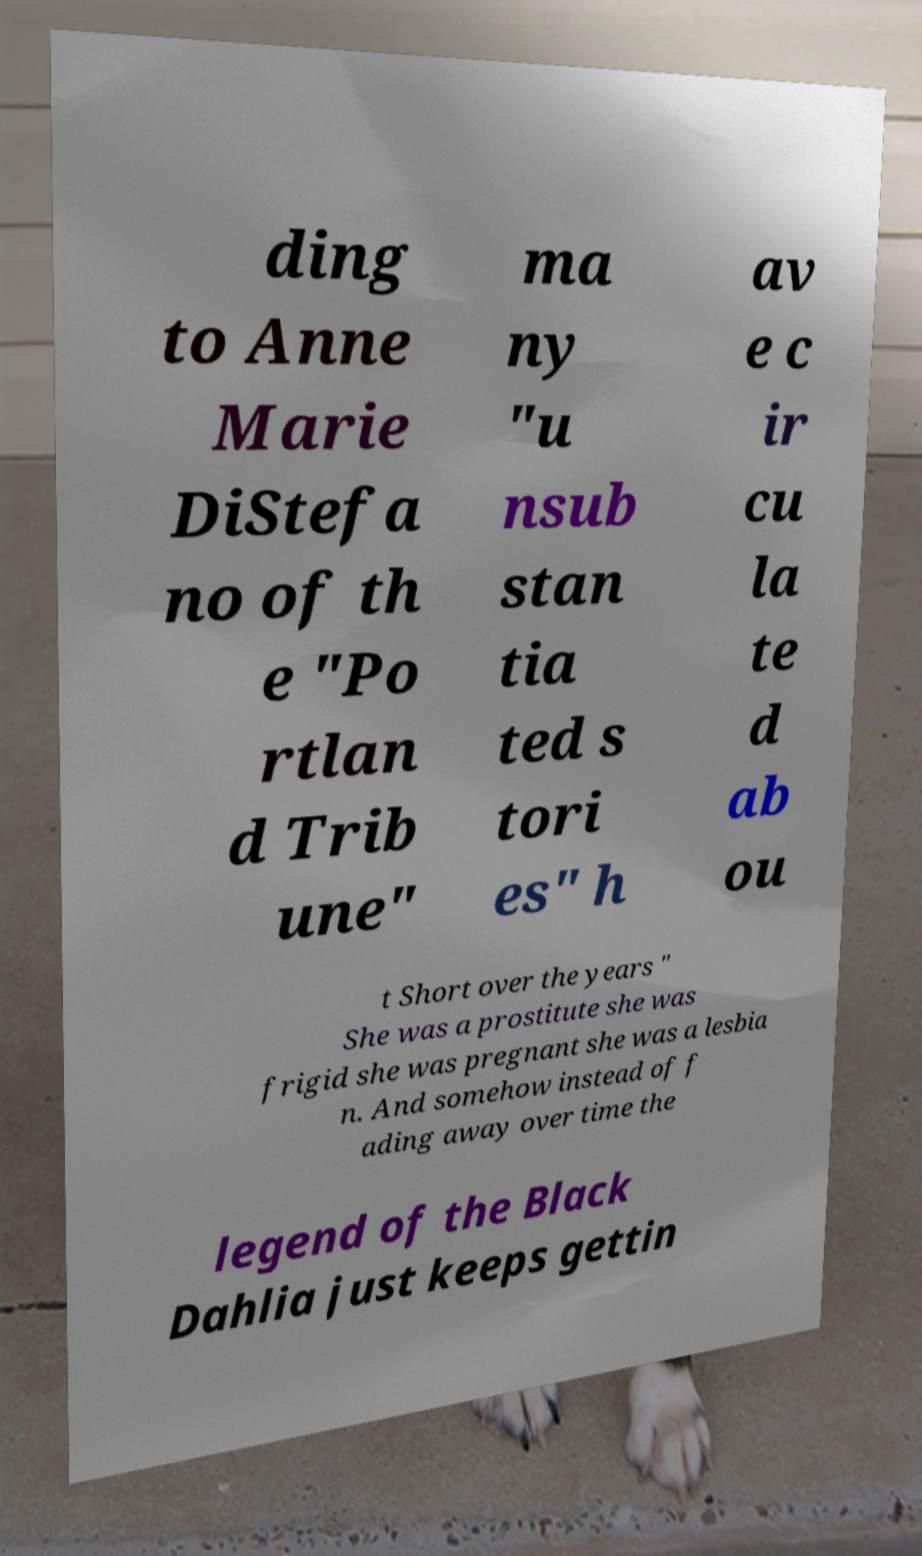Please identify and transcribe the text found in this image. ding to Anne Marie DiStefa no of th e "Po rtlan d Trib une" ma ny "u nsub stan tia ted s tori es" h av e c ir cu la te d ab ou t Short over the years " She was a prostitute she was frigid she was pregnant she was a lesbia n. And somehow instead of f ading away over time the legend of the Black Dahlia just keeps gettin 